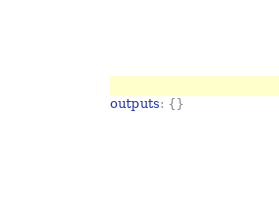Convert code to text. <code><loc_0><loc_0><loc_500><loc_500><_YAML_>outputs: {}
</code> 